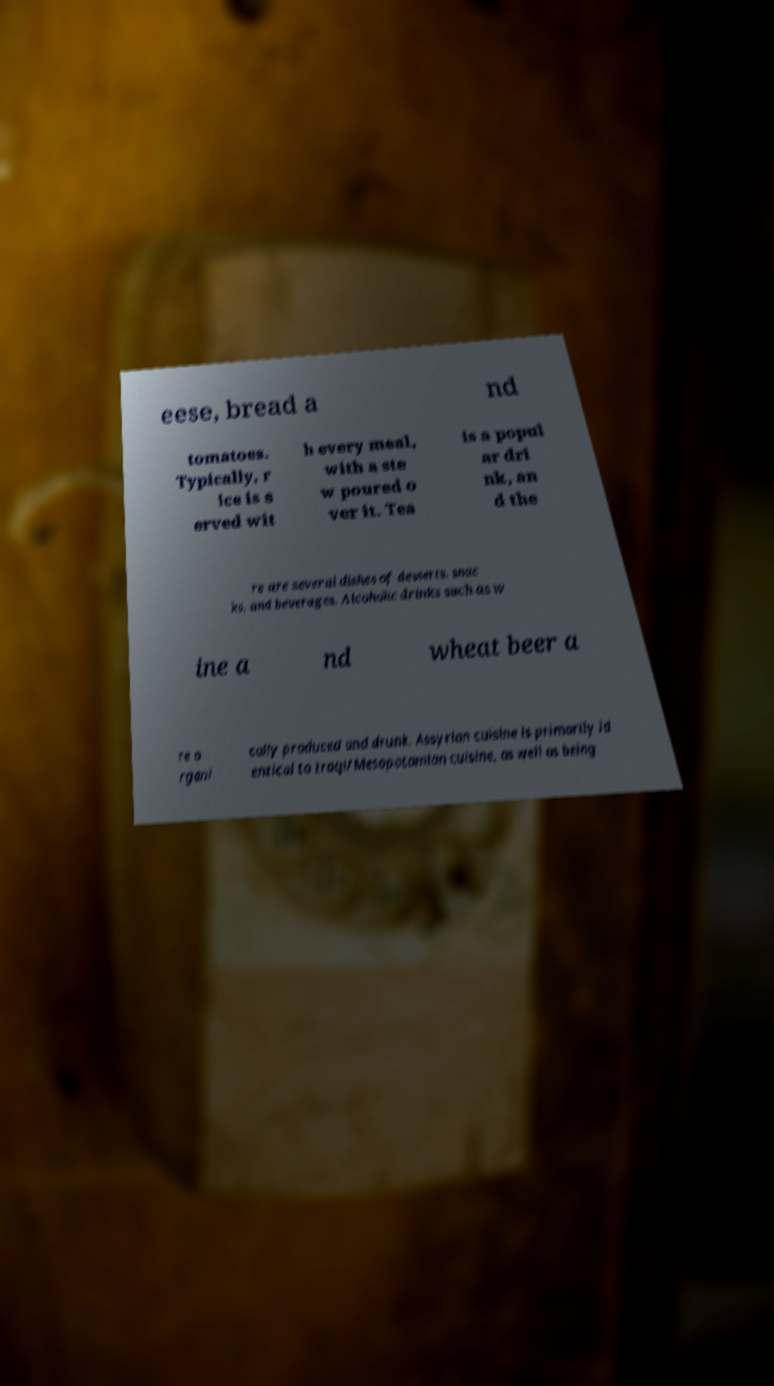I need the written content from this picture converted into text. Can you do that? eese, bread a nd tomatoes. Typically, r ice is s erved wit h every meal, with a ste w poured o ver it. Tea is a popul ar dri nk, an d the re are several dishes of desserts, snac ks, and beverages. Alcoholic drinks such as w ine a nd wheat beer a re o rgani cally produced and drunk. Assyrian cuisine is primarily id entical to Iraqi/Mesopotamian cuisine, as well as being 